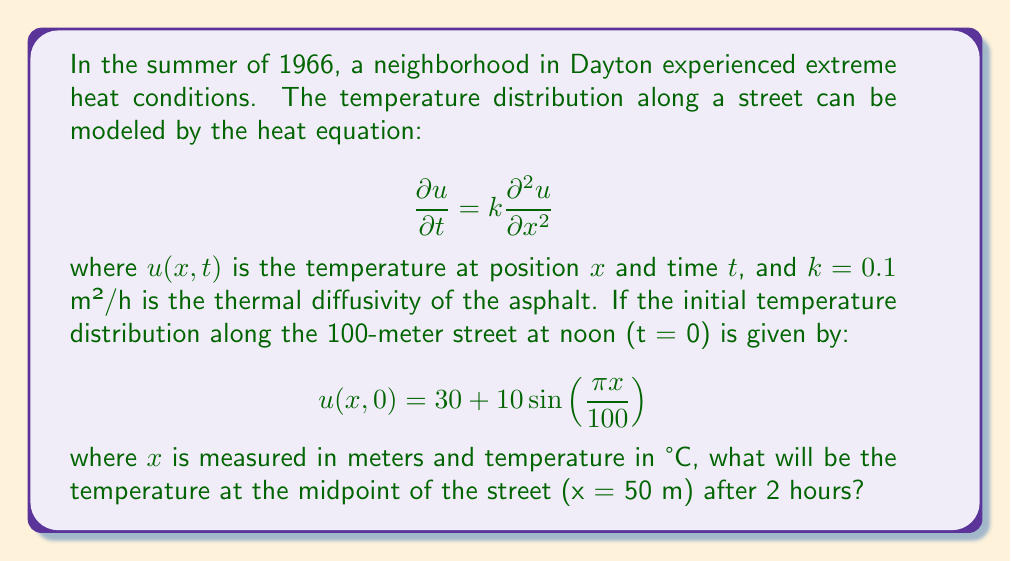Show me your answer to this math problem. To solve this problem, we need to use the solution to the heat equation with the given initial condition. The general solution for this type of problem is:

$$u(x,t) = A_0 + \sum_{n=1}^{\infty} A_n e^{-k(\frac{n\pi}{L})^2t} \sin(\frac{n\pi x}{L})$$

where $L$ is the length of the street (100 m in this case).

Step 1: Identify the coefficients from the initial condition.
$A_0 = 30$ (constant term)
$A_1 = 10$ (coefficient of the sine term)
$A_n = 0$ for $n > 1$ (no other terms in the initial condition)

Step 2: Substitute the values into the solution equation.
$$u(x,t) = 30 + 10e^{-k(\frac{\pi}{100})^2t} \sin(\frac{\pi x}{100})$$

Step 3: Calculate the exponential term for t = 2 hours.
$$e^{-k(\frac{\pi}{100})^2t} = e^{-0.1(\frac{\pi}{100})^2 \cdot 2} \approx 0.9980$$

Step 4: Evaluate the solution at x = 50 m and t = 2 h.
$$u(50,2) = 30 + 10 \cdot 0.9980 \cdot \sin(\frac{\pi \cdot 50}{100})$$
$$u(50,2) = 30 + 9.980 \cdot 1$$
$$u(50,2) = 39.980°C$$

Therefore, the temperature at the midpoint of the street after 2 hours will be approximately 39.980°C.
Answer: 39.980°C 